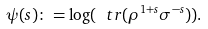Convert formula to latex. <formula><loc_0><loc_0><loc_500><loc_500>\psi ( s ) \colon = \log ( \ t r ( \rho ^ { 1 + s } \sigma ^ { - s } ) ) .</formula> 